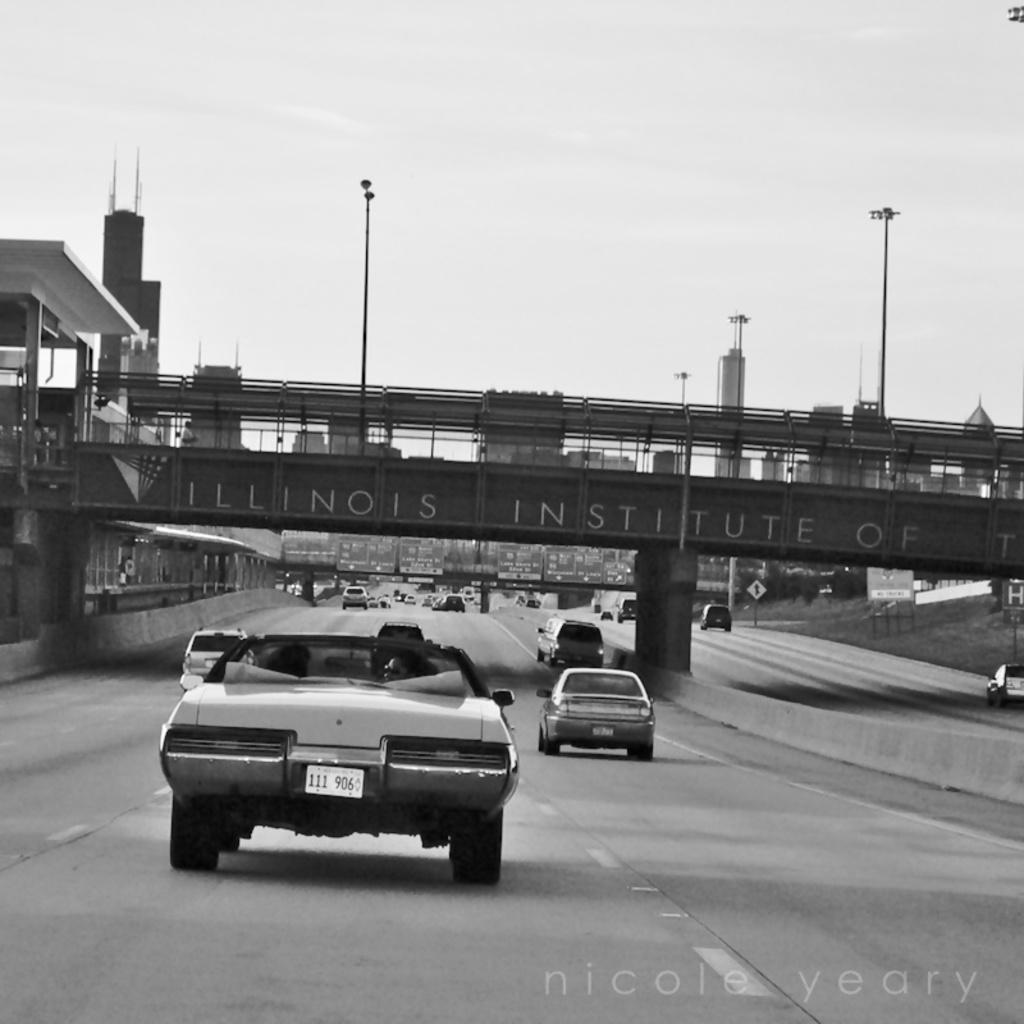What is the color scheme of the image? The image is in black and white. What can be seen on the road in the image? There are cars on the road on both sides. What structure is present in the middle of the road? There is a foot over bridge in the middle of the road. What is visible in the background of the image? There are buildings in the background. What part of the natural environment is visible in the image? The sky is visible above the buildings. What type of feast is being held on the foot over bridge in the image? There is no feast present in the image; it features a foot over bridge and cars on the road. Can you tell me how many glasses are visible on the foot over bridge? There are no glasses visible on the foot over bridge in the image. 